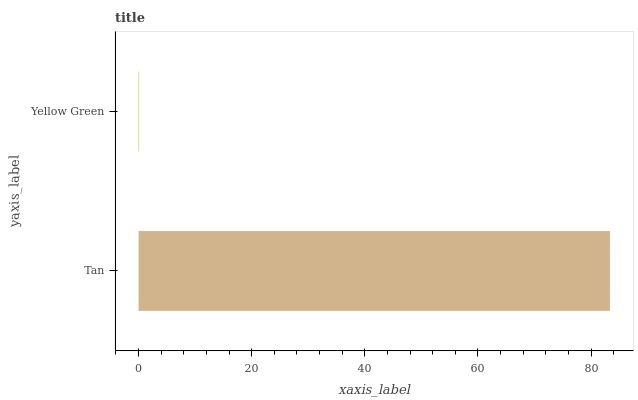Is Yellow Green the minimum?
Answer yes or no. Yes. Is Tan the maximum?
Answer yes or no. Yes. Is Yellow Green the maximum?
Answer yes or no. No. Is Tan greater than Yellow Green?
Answer yes or no. Yes. Is Yellow Green less than Tan?
Answer yes or no. Yes. Is Yellow Green greater than Tan?
Answer yes or no. No. Is Tan less than Yellow Green?
Answer yes or no. No. Is Tan the high median?
Answer yes or no. Yes. Is Yellow Green the low median?
Answer yes or no. Yes. Is Yellow Green the high median?
Answer yes or no. No. Is Tan the low median?
Answer yes or no. No. 